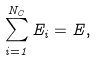Convert formula to latex. <formula><loc_0><loc_0><loc_500><loc_500>\sum _ { i = 1 } ^ { N _ { C } } E _ { i } = E ,</formula> 